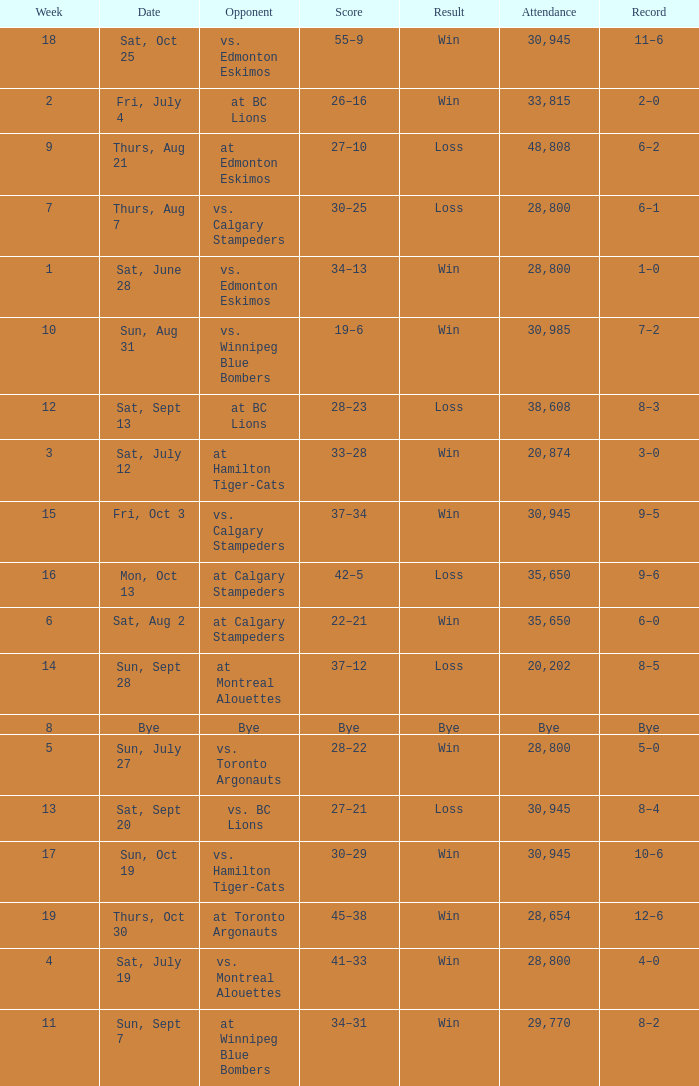What was the record the the match against vs. calgary stampeders before week 15? 6–1. 